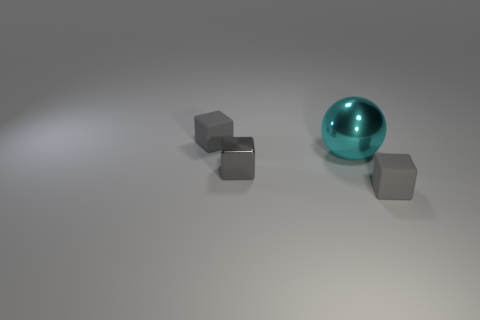Is there anything else that is the same size as the metal sphere?
Offer a very short reply. No. Are there any cubes behind the gray matte cube on the right side of the large ball?
Ensure brevity in your answer.  Yes. What material is the cyan ball?
Give a very brief answer. Metal. Does the small gray cube to the right of the big cyan object have the same material as the thing left of the metallic cube?
Your answer should be compact. Yes. Is there anything else of the same color as the shiny ball?
Offer a very short reply. No. There is a thing that is on the left side of the big cyan object and behind the small shiny thing; what size is it?
Your answer should be compact. Small. There is a object to the right of the big cyan metallic thing; is it the same shape as the gray rubber object left of the tiny gray shiny object?
Provide a succinct answer. Yes. What number of large things have the same material as the cyan sphere?
Your answer should be very brief. 0. What shape is the gray object that is both left of the cyan object and in front of the cyan shiny sphere?
Keep it short and to the point. Cube. Does the gray object that is in front of the small gray shiny object have the same material as the cyan ball?
Offer a very short reply. No. 